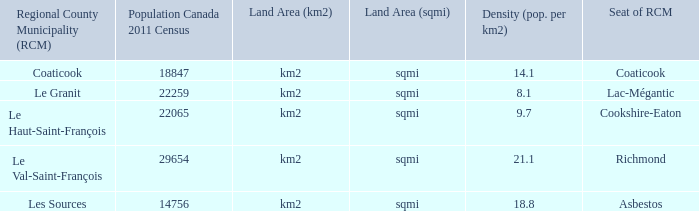What is the seat of the county that has a density of 14.1? Coaticook. 